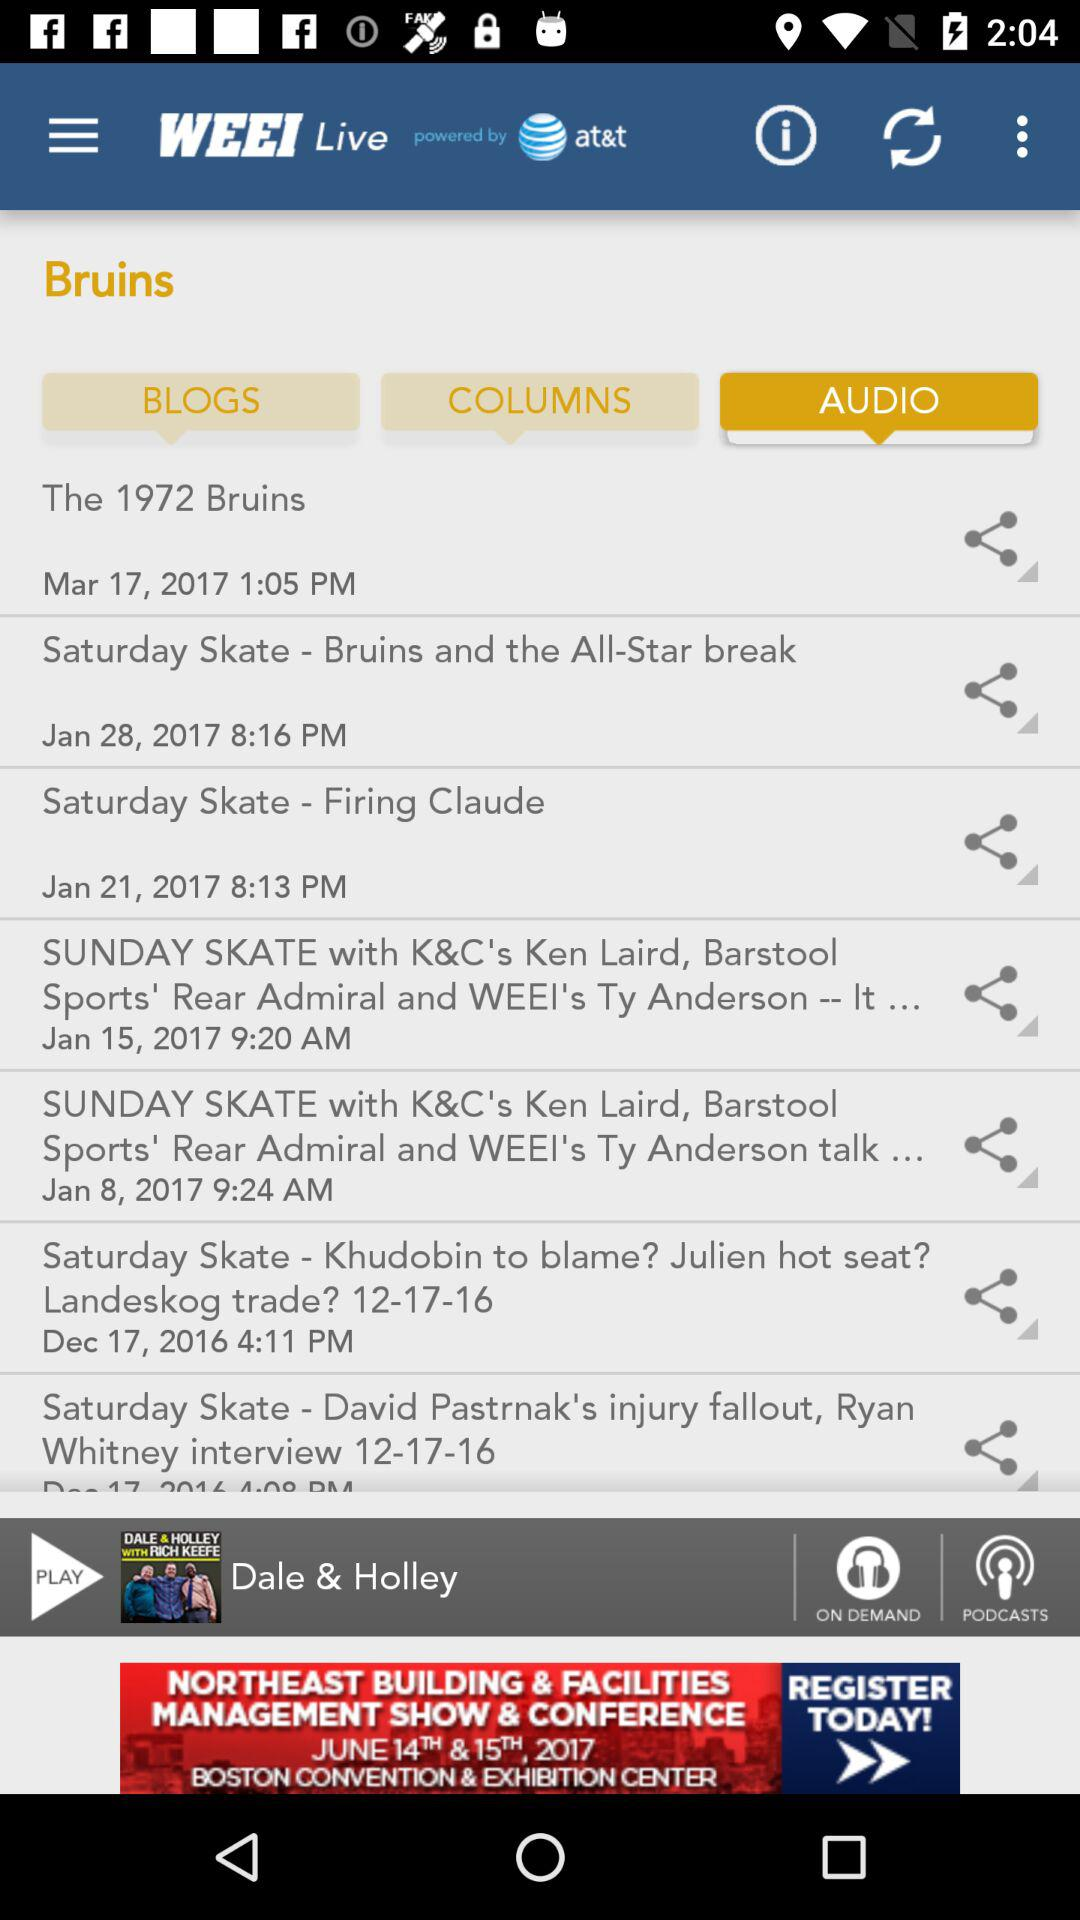Which company has powered "WEEI Live" app? The company is "at&t". 